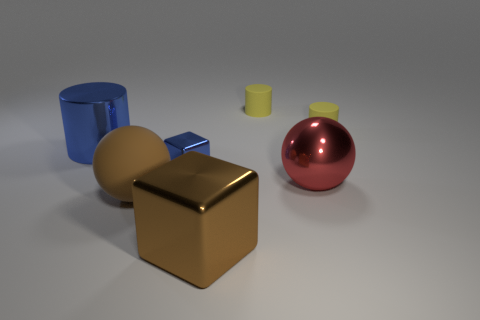What number of big red objects are the same shape as the large brown rubber thing?
Provide a short and direct response. 1. There is a brown object that is the same size as the brown matte ball; what is its shape?
Give a very brief answer. Cube. There is a tiny metallic thing; are there any large blue cylinders behind it?
Ensure brevity in your answer.  Yes. Is there a yellow matte cylinder that is behind the small object right of the large red shiny thing?
Offer a terse response. Yes. Is the number of big blue metallic objects that are in front of the large metallic sphere less than the number of blue objects behind the blue cube?
Your answer should be compact. Yes. The large brown rubber thing is what shape?
Provide a short and direct response. Sphere. What material is the thing right of the metallic ball?
Keep it short and to the point. Rubber. What size is the metallic block that is to the right of the metallic cube behind the rubber thing that is in front of the tiny blue metallic thing?
Provide a succinct answer. Large. Is the big brown ball in front of the large blue metallic cylinder made of the same material as the cube that is in front of the large metal sphere?
Your answer should be compact. No. How many other things are there of the same color as the big metal ball?
Keep it short and to the point. 0. 